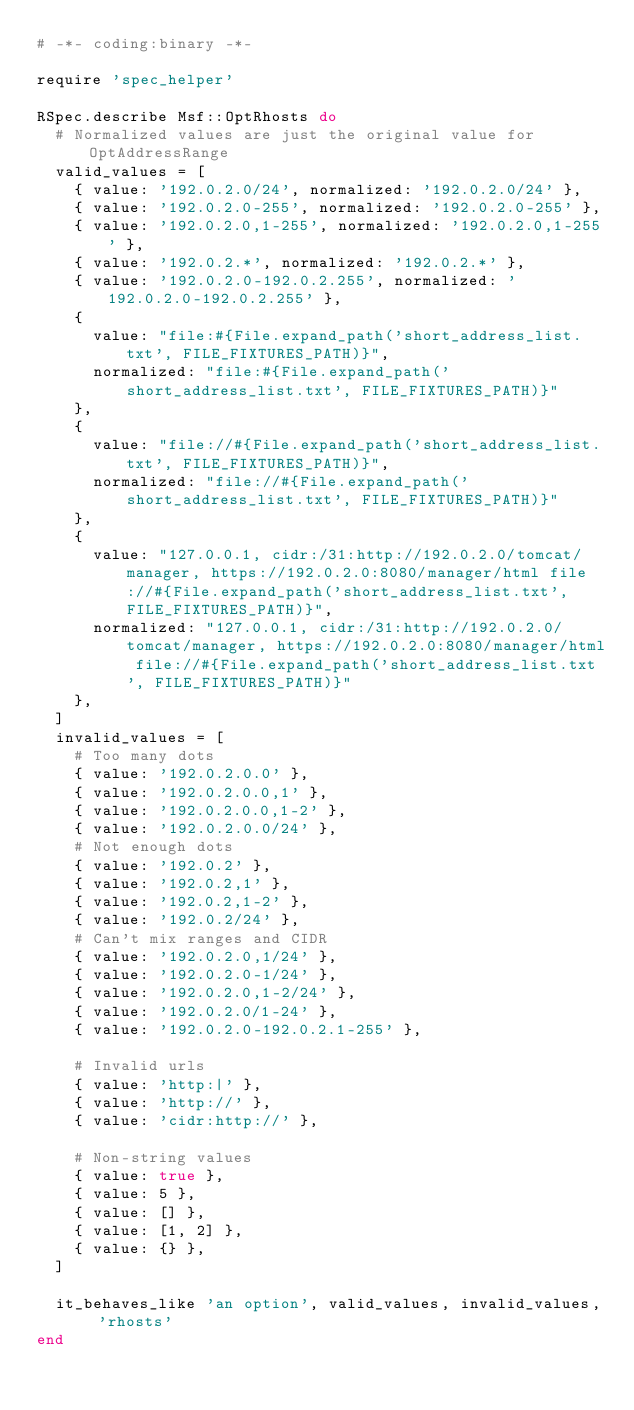Convert code to text. <code><loc_0><loc_0><loc_500><loc_500><_Ruby_># -*- coding:binary -*-

require 'spec_helper'

RSpec.describe Msf::OptRhosts do
  # Normalized values are just the original value for OptAddressRange
  valid_values = [
    { value: '192.0.2.0/24', normalized: '192.0.2.0/24' },
    { value: '192.0.2.0-255', normalized: '192.0.2.0-255' },
    { value: '192.0.2.0,1-255', normalized: '192.0.2.0,1-255' },
    { value: '192.0.2.*', normalized: '192.0.2.*' },
    { value: '192.0.2.0-192.0.2.255', normalized: '192.0.2.0-192.0.2.255' },
    {
      value: "file:#{File.expand_path('short_address_list.txt', FILE_FIXTURES_PATH)}",
      normalized: "file:#{File.expand_path('short_address_list.txt', FILE_FIXTURES_PATH)}"
    },
    {
      value: "file://#{File.expand_path('short_address_list.txt', FILE_FIXTURES_PATH)}",
      normalized: "file://#{File.expand_path('short_address_list.txt', FILE_FIXTURES_PATH)}"
    },
    {
      value: "127.0.0.1, cidr:/31:http://192.0.2.0/tomcat/manager, https://192.0.2.0:8080/manager/html file://#{File.expand_path('short_address_list.txt', FILE_FIXTURES_PATH)}",
      normalized: "127.0.0.1, cidr:/31:http://192.0.2.0/tomcat/manager, https://192.0.2.0:8080/manager/html file://#{File.expand_path('short_address_list.txt', FILE_FIXTURES_PATH)}"
    },
  ]
  invalid_values = [
    # Too many dots
    { value: '192.0.2.0.0' },
    { value: '192.0.2.0.0,1' },
    { value: '192.0.2.0.0,1-2' },
    { value: '192.0.2.0.0/24' },
    # Not enough dots
    { value: '192.0.2' },
    { value: '192.0.2,1' },
    { value: '192.0.2,1-2' },
    { value: '192.0.2/24' },
    # Can't mix ranges and CIDR
    { value: '192.0.2.0,1/24' },
    { value: '192.0.2.0-1/24' },
    { value: '192.0.2.0,1-2/24' },
    { value: '192.0.2.0/1-24' },
    { value: '192.0.2.0-192.0.2.1-255' },

    # Invalid urls
    { value: 'http:|' },
    { value: 'http://' },
    { value: 'cidr:http://' },

    # Non-string values
    { value: true },
    { value: 5 },
    { value: [] },
    { value: [1, 2] },
    { value: {} },
  ]

  it_behaves_like 'an option', valid_values, invalid_values, 'rhosts'
end
</code> 